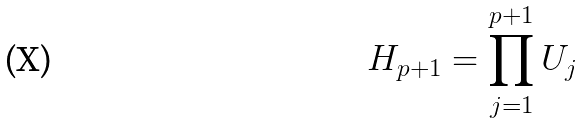<formula> <loc_0><loc_0><loc_500><loc_500>H _ { p + 1 } = \prod _ { j = 1 } ^ { p + 1 } U _ { j }</formula> 